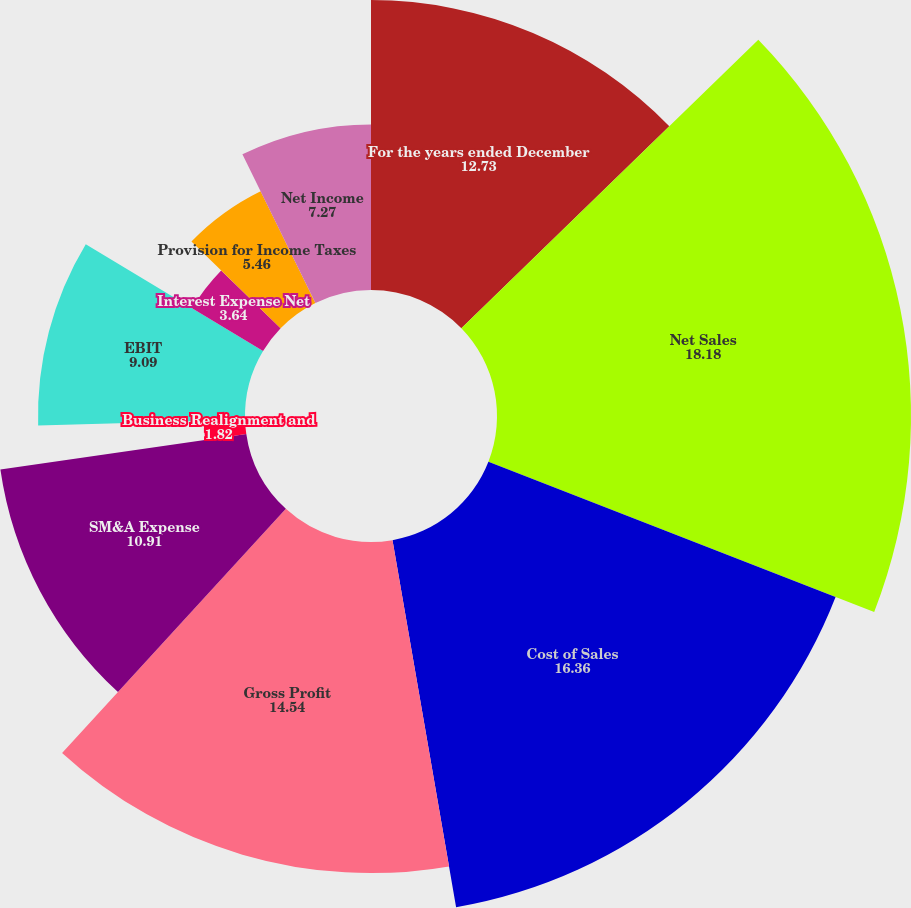Convert chart. <chart><loc_0><loc_0><loc_500><loc_500><pie_chart><fcel>For the years ended December<fcel>Net Sales<fcel>Cost of Sales<fcel>Gross Profit<fcel>SM&A Expense<fcel>Business Realignment and<fcel>EBIT<fcel>Interest Expense Net<fcel>Provision for Income Taxes<fcel>Net Income<nl><fcel>12.73%<fcel>18.18%<fcel>16.36%<fcel>14.54%<fcel>10.91%<fcel>1.82%<fcel>9.09%<fcel>3.64%<fcel>5.46%<fcel>7.27%<nl></chart> 